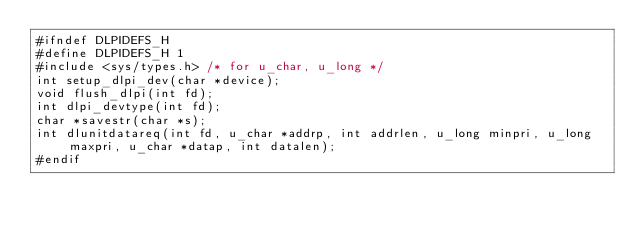Convert code to text. <code><loc_0><loc_0><loc_500><loc_500><_C_>#ifndef DLPIDEFS_H
#define DLPIDEFS_H 1
#include <sys/types.h> /* for u_char, u_long */
int setup_dlpi_dev(char *device);
void flush_dlpi(int fd);
int dlpi_devtype(int fd);
char *savestr(char *s);
int dlunitdatareq(int fd, u_char *addrp, int addrlen, u_long minpri, u_long maxpri, u_char *datap, int datalen);
#endif
</code> 